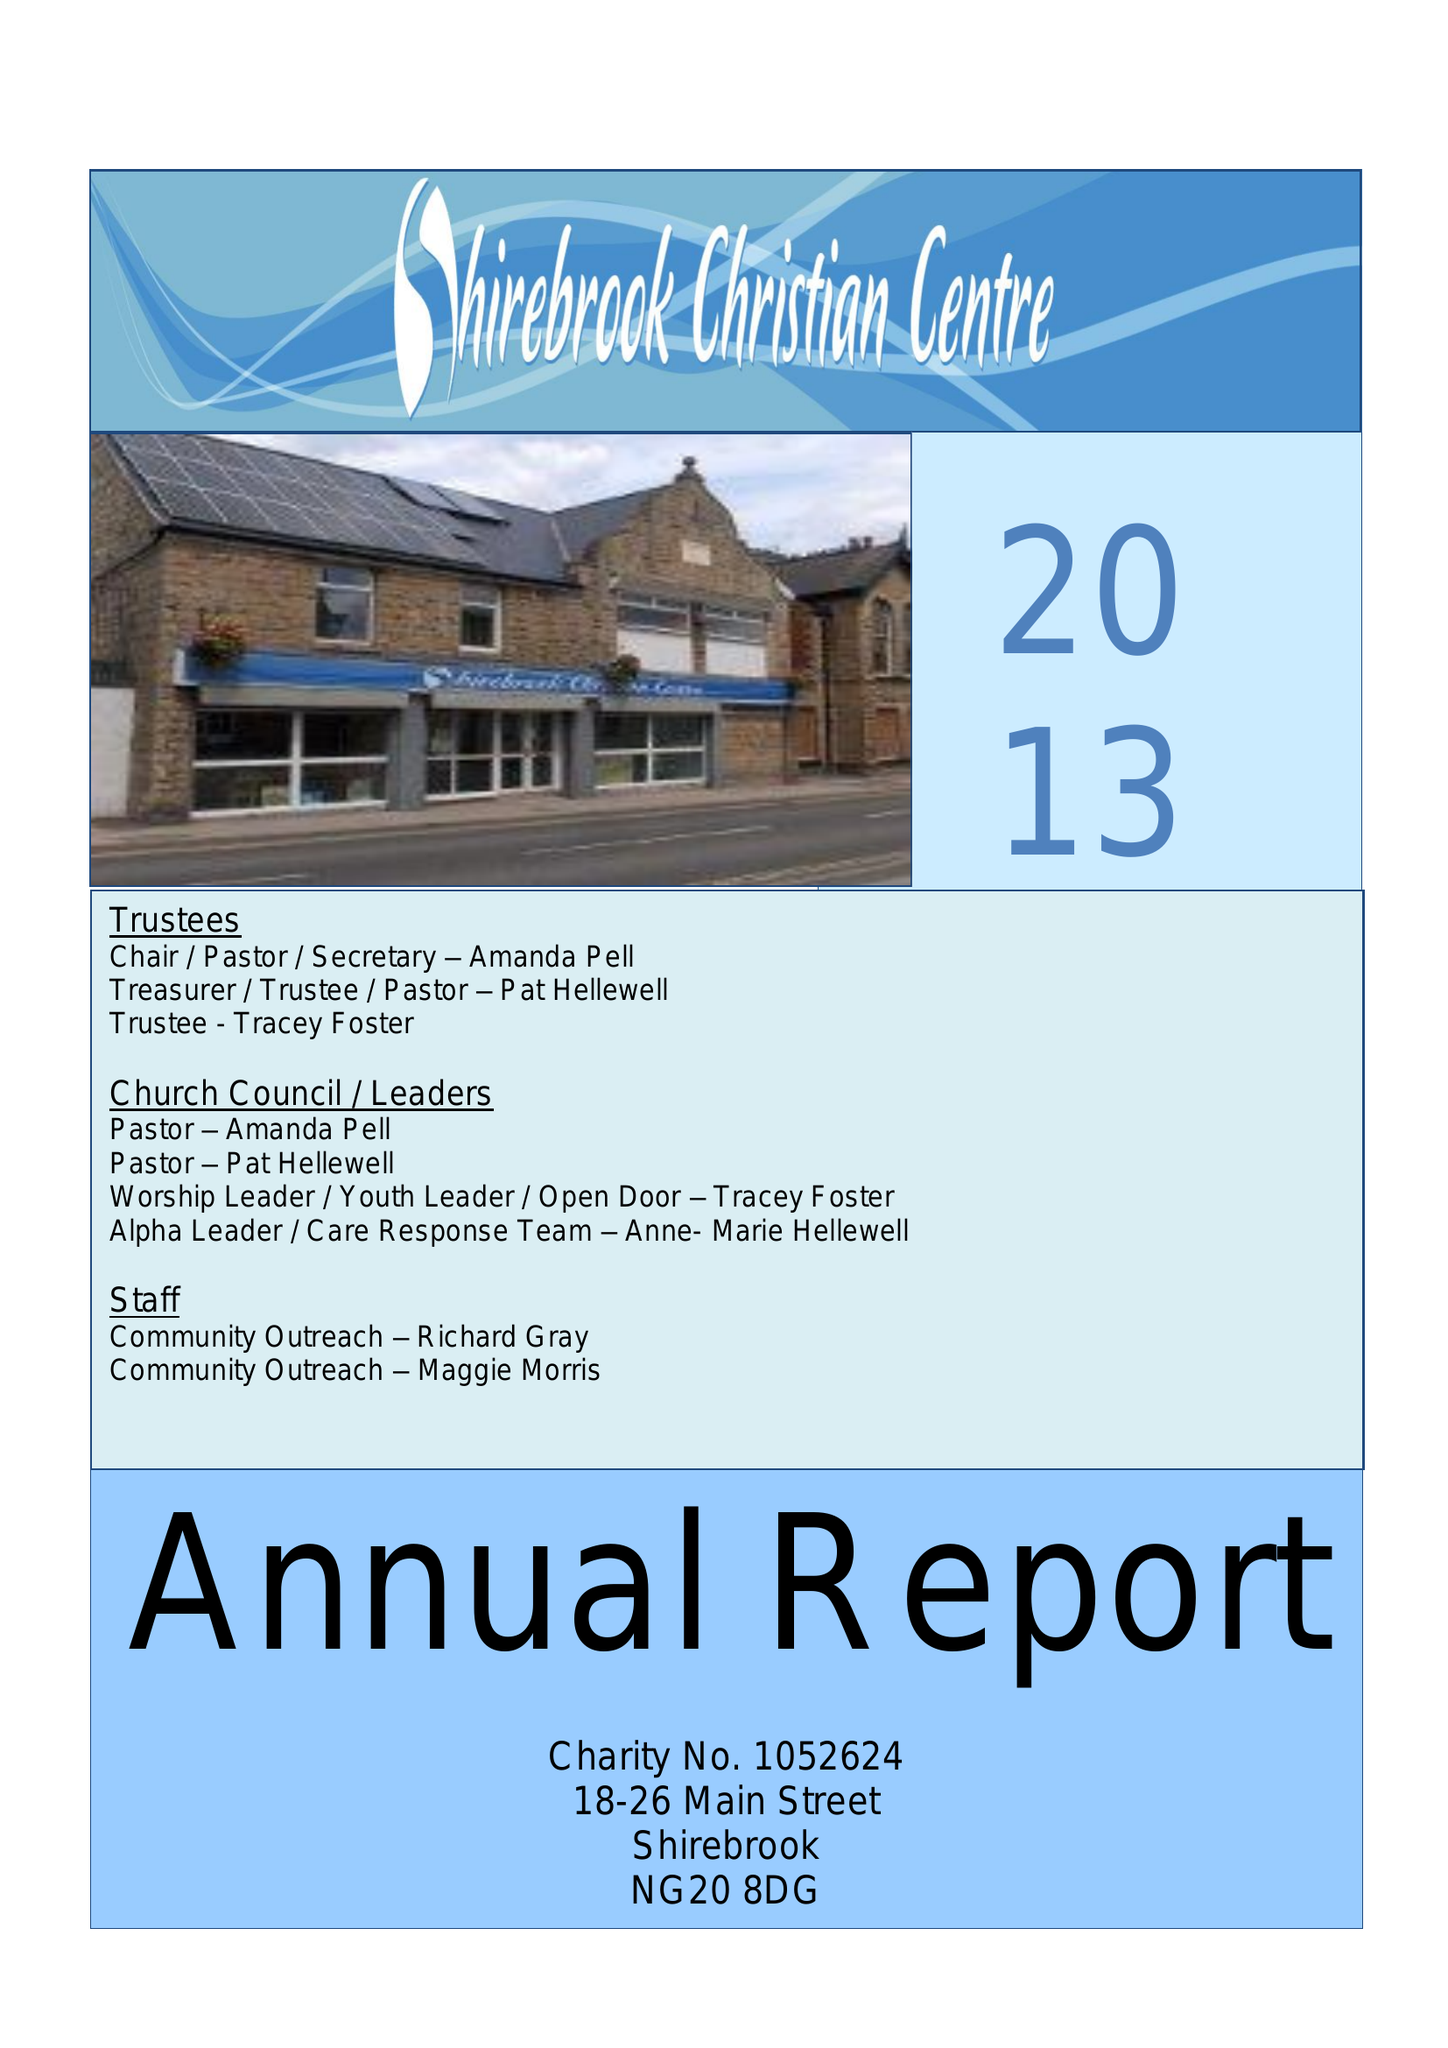What is the value for the charity_number?
Answer the question using a single word or phrase. 1052624 